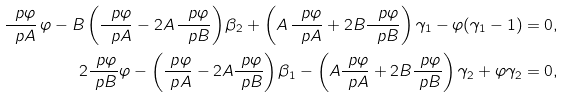Convert formula to latex. <formula><loc_0><loc_0><loc_500><loc_500>\frac { \ p \varphi } { \ p A } \, \varphi - B \left ( \frac { \ p \varphi } { \ p A } - 2 A \, \frac { \ p \varphi } { \ p B } \right ) \beta _ { 2 } + \left ( A \, \frac { \ p \varphi } { \ p A } + 2 B \frac { \ p \varphi } { \ p B } \right ) \gamma _ { 1 } - \varphi ( \gamma _ { 1 } - 1 ) & = 0 , \\ 2 \frac { \ p \varphi } { \ p B } \varphi - \left ( \frac { \ p \varphi } { \ p A } - 2 A \frac { \ p \varphi } { \ p B } \right ) \beta _ { 1 } - \left ( A \frac { \ p \varphi } { \ p A } + 2 B \frac { \ p \varphi } { \ p B } \right ) \gamma _ { 2 } + \varphi \gamma _ { 2 } & = 0 ,</formula> 